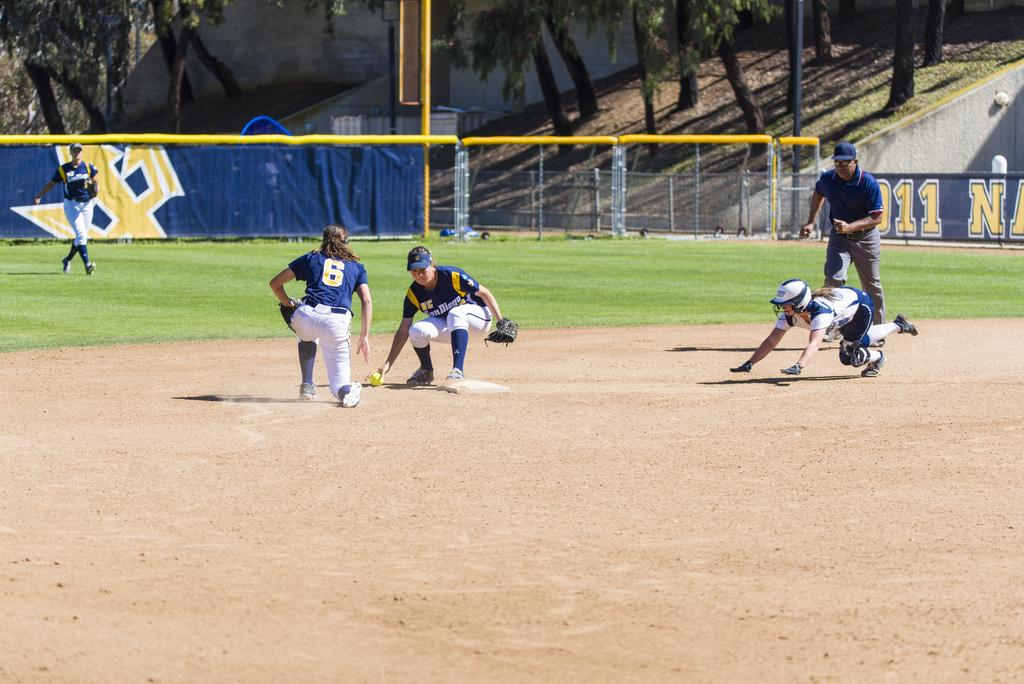<image>
Write a terse but informative summary of the picture. People playing baseball on a field with the number 11 on the side. 